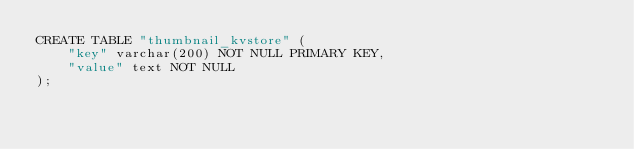Convert code to text. <code><loc_0><loc_0><loc_500><loc_500><_SQL_>CREATE TABLE "thumbnail_kvstore" (
    "key" varchar(200) NOT NULL PRIMARY KEY,
    "value" text NOT NULL
);</code> 